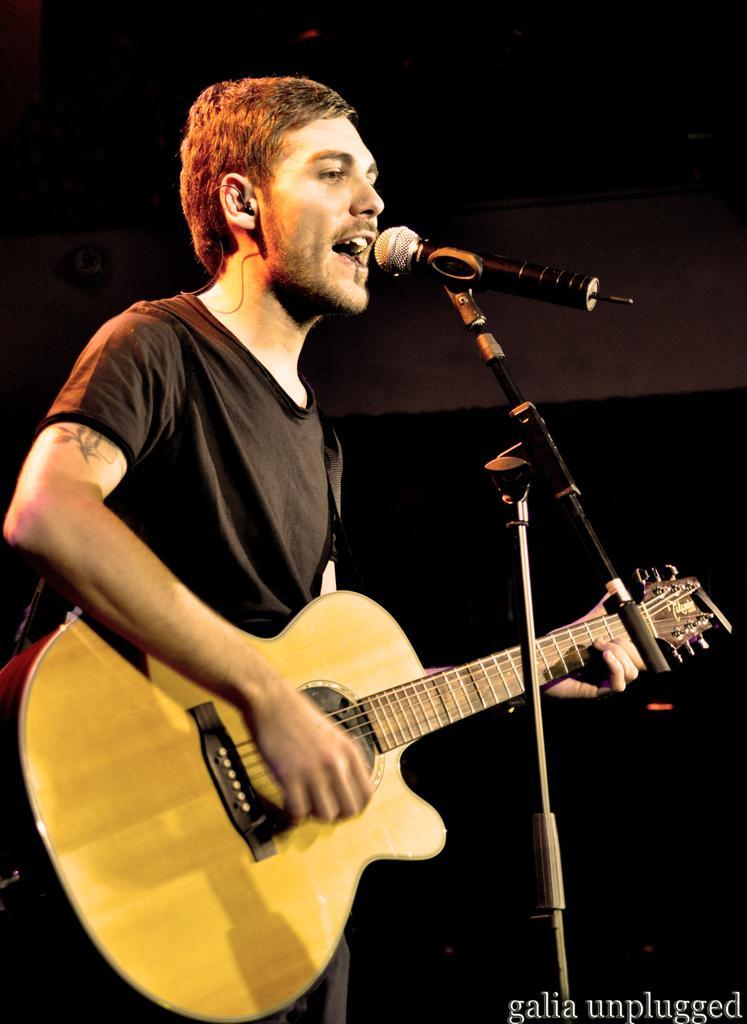Describe this image in one or two sentences. As we can see in the image there is a man standing singing on mike and holding guitar in his hands. 